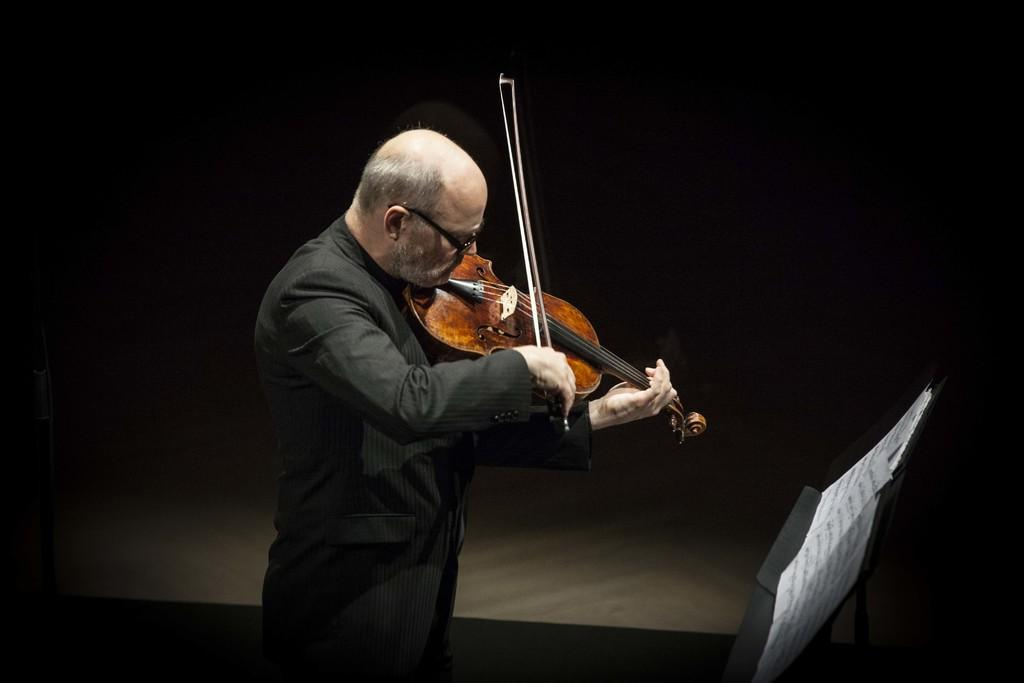Who is the person in the image? There is a man in the image. What is the man wearing? The man is wearing a black blazer and spectacles. What is the man doing in the image? The man is playing a violin. What is in front of the man? There is a board in front of the man. What is on the board? There are papers on the board. What can be observed about the background of the image? The background of the image is dark. What type of insect can be seen on the violin in the image? There is no insect present in the image. 